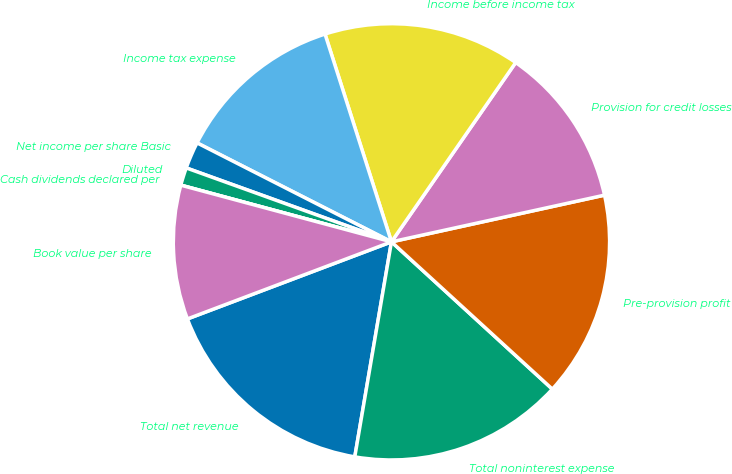Convert chart. <chart><loc_0><loc_0><loc_500><loc_500><pie_chart><fcel>Total net revenue<fcel>Total noninterest expense<fcel>Pre-provision profit<fcel>Provision for credit losses<fcel>Income before income tax<fcel>Income tax expense<fcel>Net income per share Basic<fcel>Diluted<fcel>Cash dividends declared per<fcel>Book value per share<nl><fcel>16.56%<fcel>15.89%<fcel>15.23%<fcel>11.92%<fcel>14.57%<fcel>12.58%<fcel>1.99%<fcel>1.32%<fcel>0.0%<fcel>9.93%<nl></chart> 